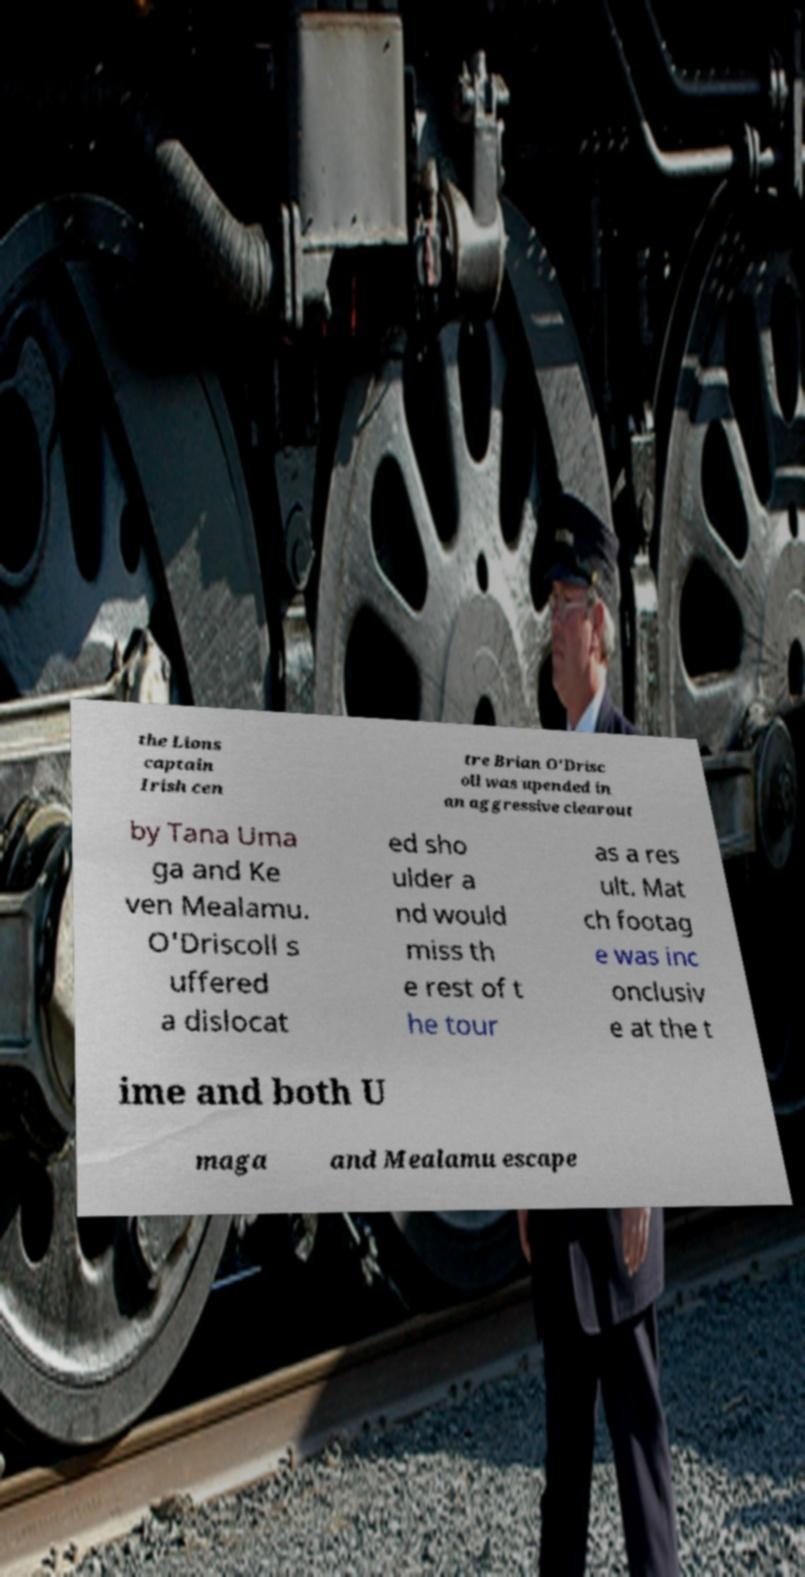Can you accurately transcribe the text from the provided image for me? the Lions captain Irish cen tre Brian O'Drisc oll was upended in an aggressive clearout by Tana Uma ga and Ke ven Mealamu. O'Driscoll s uffered a dislocat ed sho ulder a nd would miss th e rest of t he tour as a res ult. Mat ch footag e was inc onclusiv e at the t ime and both U maga and Mealamu escape 